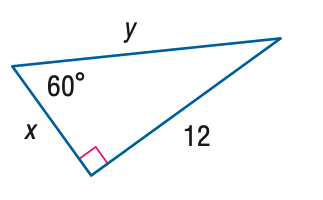Question: Find x.
Choices:
A. 4 \sqrt { 2 }
B. 4 \sqrt { 3 }
C. 8 \sqrt { 2 }
D. 8 \sqrt { 3 }
Answer with the letter. Answer: B 